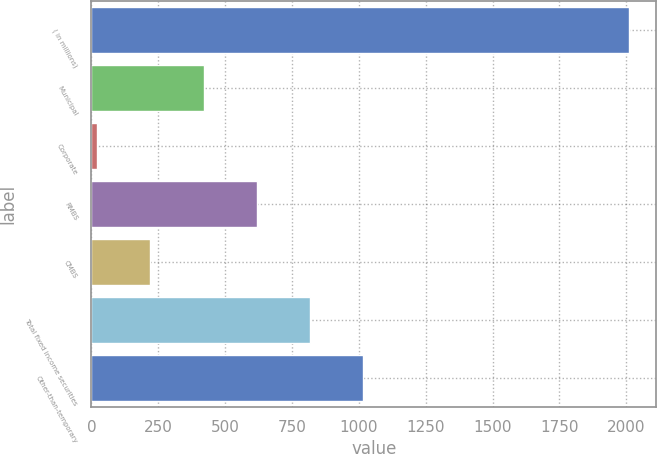Convert chart. <chart><loc_0><loc_0><loc_500><loc_500><bar_chart><fcel>( in millions)<fcel>Municipal<fcel>Corporate<fcel>RMBS<fcel>CMBS<fcel>Total fixed income securities<fcel>Other-than-temporary<nl><fcel>2012<fcel>419.2<fcel>21<fcel>618.3<fcel>220.1<fcel>817.4<fcel>1016.5<nl></chart> 